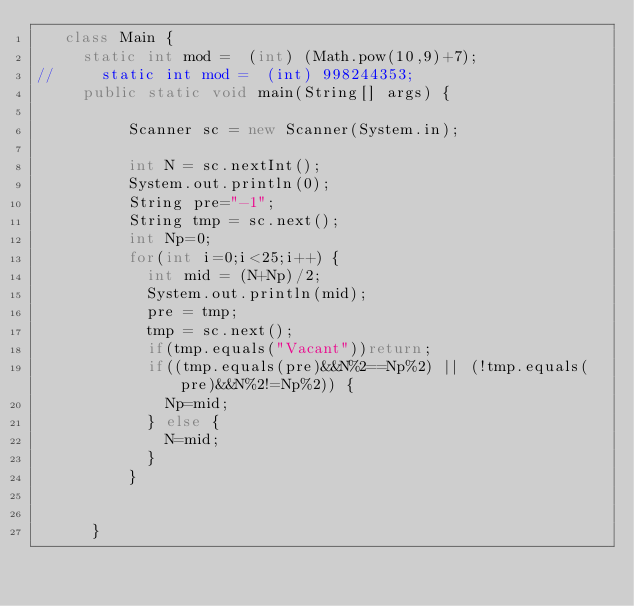Convert code to text. <code><loc_0><loc_0><loc_500><loc_500><_Java_>	 class Main {
		 static int mod =  (int) (Math.pow(10,9)+7);
//		 static int mod =  (int) 998244353;
		 public static void main(String[] args) {
	    	
	        Scanner sc = new Scanner(System.in);

	        int N = sc.nextInt();
	        System.out.println(0);
	        String pre="-1";
        	String tmp = sc.next();
	        int Np=0;
	        for(int i=0;i<25;i++) {
	        	int mid = (N+Np)/2;
	        	System.out.println(mid);
	        	pre = tmp;
	        	tmp = sc.next();
	        	if(tmp.equals("Vacant"))return;
	        	if((tmp.equals(pre)&&N%2==Np%2) || (!tmp.equals(pre)&&N%2!=Np%2)) {
	        		Np=mid;
	        	} else {
	        		N=mid;
	        	}
	        }
	        
	       
	    }</code> 